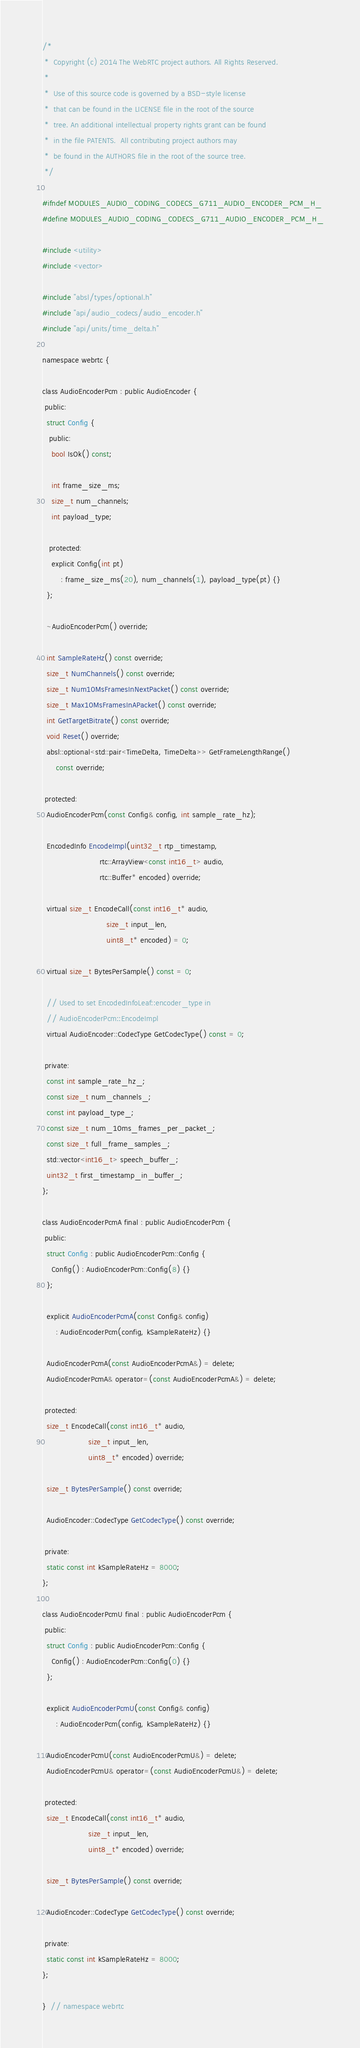<code> <loc_0><loc_0><loc_500><loc_500><_C_>/*
 *  Copyright (c) 2014 The WebRTC project authors. All Rights Reserved.
 *
 *  Use of this source code is governed by a BSD-style license
 *  that can be found in the LICENSE file in the root of the source
 *  tree. An additional intellectual property rights grant can be found
 *  in the file PATENTS.  All contributing project authors may
 *  be found in the AUTHORS file in the root of the source tree.
 */

#ifndef MODULES_AUDIO_CODING_CODECS_G711_AUDIO_ENCODER_PCM_H_
#define MODULES_AUDIO_CODING_CODECS_G711_AUDIO_ENCODER_PCM_H_

#include <utility>
#include <vector>

#include "absl/types/optional.h"
#include "api/audio_codecs/audio_encoder.h"
#include "api/units/time_delta.h"

namespace webrtc {

class AudioEncoderPcm : public AudioEncoder {
 public:
  struct Config {
   public:
    bool IsOk() const;

    int frame_size_ms;
    size_t num_channels;
    int payload_type;

   protected:
    explicit Config(int pt)
        : frame_size_ms(20), num_channels(1), payload_type(pt) {}
  };

  ~AudioEncoderPcm() override;

  int SampleRateHz() const override;
  size_t NumChannels() const override;
  size_t Num10MsFramesInNextPacket() const override;
  size_t Max10MsFramesInAPacket() const override;
  int GetTargetBitrate() const override;
  void Reset() override;
  absl::optional<std::pair<TimeDelta, TimeDelta>> GetFrameLengthRange()
      const override;

 protected:
  AudioEncoderPcm(const Config& config, int sample_rate_hz);

  EncodedInfo EncodeImpl(uint32_t rtp_timestamp,
                         rtc::ArrayView<const int16_t> audio,
                         rtc::Buffer* encoded) override;

  virtual size_t EncodeCall(const int16_t* audio,
                            size_t input_len,
                            uint8_t* encoded) = 0;

  virtual size_t BytesPerSample() const = 0;

  // Used to set EncodedInfoLeaf::encoder_type in
  // AudioEncoderPcm::EncodeImpl
  virtual AudioEncoder::CodecType GetCodecType() const = 0;

 private:
  const int sample_rate_hz_;
  const size_t num_channels_;
  const int payload_type_;
  const size_t num_10ms_frames_per_packet_;
  const size_t full_frame_samples_;
  std::vector<int16_t> speech_buffer_;
  uint32_t first_timestamp_in_buffer_;
};

class AudioEncoderPcmA final : public AudioEncoderPcm {
 public:
  struct Config : public AudioEncoderPcm::Config {
    Config() : AudioEncoderPcm::Config(8) {}
  };

  explicit AudioEncoderPcmA(const Config& config)
      : AudioEncoderPcm(config, kSampleRateHz) {}

  AudioEncoderPcmA(const AudioEncoderPcmA&) = delete;
  AudioEncoderPcmA& operator=(const AudioEncoderPcmA&) = delete;

 protected:
  size_t EncodeCall(const int16_t* audio,
                    size_t input_len,
                    uint8_t* encoded) override;

  size_t BytesPerSample() const override;

  AudioEncoder::CodecType GetCodecType() const override;

 private:
  static const int kSampleRateHz = 8000;
};

class AudioEncoderPcmU final : public AudioEncoderPcm {
 public:
  struct Config : public AudioEncoderPcm::Config {
    Config() : AudioEncoderPcm::Config(0) {}
  };

  explicit AudioEncoderPcmU(const Config& config)
      : AudioEncoderPcm(config, kSampleRateHz) {}

  AudioEncoderPcmU(const AudioEncoderPcmU&) = delete;
  AudioEncoderPcmU& operator=(const AudioEncoderPcmU&) = delete;

 protected:
  size_t EncodeCall(const int16_t* audio,
                    size_t input_len,
                    uint8_t* encoded) override;

  size_t BytesPerSample() const override;

  AudioEncoder::CodecType GetCodecType() const override;

 private:
  static const int kSampleRateHz = 8000;
};

}  // namespace webrtc
</code> 